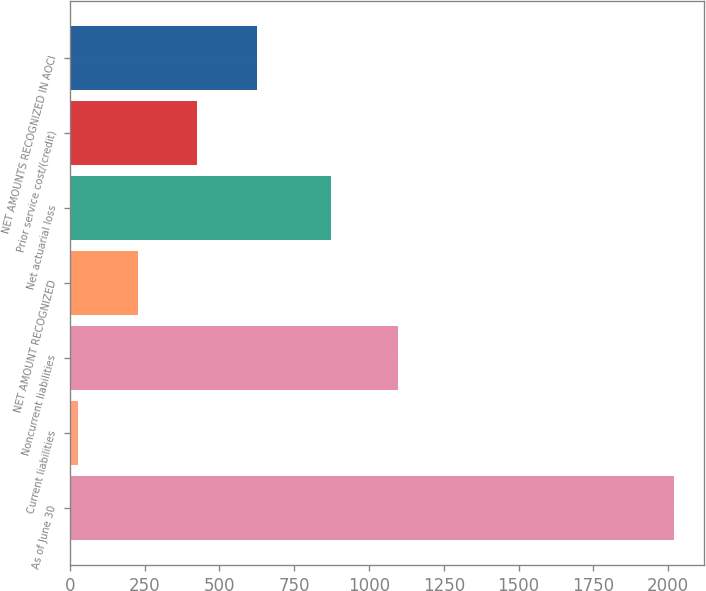Convert chart to OTSL. <chart><loc_0><loc_0><loc_500><loc_500><bar_chart><fcel>As of June 30<fcel>Current liabilities<fcel>Noncurrent liabilities<fcel>NET AMOUNT RECOGNIZED<fcel>Net actuarial loss<fcel>Prior service cost/(credit)<fcel>NET AMOUNTS RECOGNIZED IN AOCI<nl><fcel>2019<fcel>27<fcel>1098<fcel>226.2<fcel>874<fcel>425.4<fcel>624.6<nl></chart> 